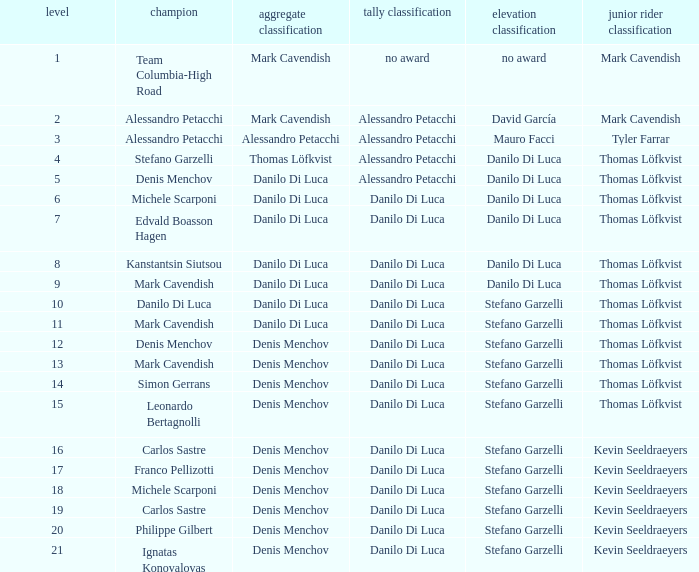Parse the full table. {'header': ['level', 'champion', 'aggregate classification', 'tally classification', 'elevation classification', 'junior rider classification'], 'rows': [['1', 'Team Columbia-High Road', 'Mark Cavendish', 'no award', 'no award', 'Mark Cavendish'], ['2', 'Alessandro Petacchi', 'Mark Cavendish', 'Alessandro Petacchi', 'David García', 'Mark Cavendish'], ['3', 'Alessandro Petacchi', 'Alessandro Petacchi', 'Alessandro Petacchi', 'Mauro Facci', 'Tyler Farrar'], ['4', 'Stefano Garzelli', 'Thomas Löfkvist', 'Alessandro Petacchi', 'Danilo Di Luca', 'Thomas Löfkvist'], ['5', 'Denis Menchov', 'Danilo Di Luca', 'Alessandro Petacchi', 'Danilo Di Luca', 'Thomas Löfkvist'], ['6', 'Michele Scarponi', 'Danilo Di Luca', 'Danilo Di Luca', 'Danilo Di Luca', 'Thomas Löfkvist'], ['7', 'Edvald Boasson Hagen', 'Danilo Di Luca', 'Danilo Di Luca', 'Danilo Di Luca', 'Thomas Löfkvist'], ['8', 'Kanstantsin Siutsou', 'Danilo Di Luca', 'Danilo Di Luca', 'Danilo Di Luca', 'Thomas Löfkvist'], ['9', 'Mark Cavendish', 'Danilo Di Luca', 'Danilo Di Luca', 'Danilo Di Luca', 'Thomas Löfkvist'], ['10', 'Danilo Di Luca', 'Danilo Di Luca', 'Danilo Di Luca', 'Stefano Garzelli', 'Thomas Löfkvist'], ['11', 'Mark Cavendish', 'Danilo Di Luca', 'Danilo Di Luca', 'Stefano Garzelli', 'Thomas Löfkvist'], ['12', 'Denis Menchov', 'Denis Menchov', 'Danilo Di Luca', 'Stefano Garzelli', 'Thomas Löfkvist'], ['13', 'Mark Cavendish', 'Denis Menchov', 'Danilo Di Luca', 'Stefano Garzelli', 'Thomas Löfkvist'], ['14', 'Simon Gerrans', 'Denis Menchov', 'Danilo Di Luca', 'Stefano Garzelli', 'Thomas Löfkvist'], ['15', 'Leonardo Bertagnolli', 'Denis Menchov', 'Danilo Di Luca', 'Stefano Garzelli', 'Thomas Löfkvist'], ['16', 'Carlos Sastre', 'Denis Menchov', 'Danilo Di Luca', 'Stefano Garzelli', 'Kevin Seeldraeyers'], ['17', 'Franco Pellizotti', 'Denis Menchov', 'Danilo Di Luca', 'Stefano Garzelli', 'Kevin Seeldraeyers'], ['18', 'Michele Scarponi', 'Denis Menchov', 'Danilo Di Luca', 'Stefano Garzelli', 'Kevin Seeldraeyers'], ['19', 'Carlos Sastre', 'Denis Menchov', 'Danilo Di Luca', 'Stefano Garzelli', 'Kevin Seeldraeyers'], ['20', 'Philippe Gilbert', 'Denis Menchov', 'Danilo Di Luca', 'Stefano Garzelli', 'Kevin Seeldraeyers'], ['21', 'Ignatas Konovalovas', 'Denis Menchov', 'Danilo Di Luca', 'Stefano Garzelli', 'Kevin Seeldraeyers']]} When  thomas löfkvist is the general classification who is the winner? Stefano Garzelli. 